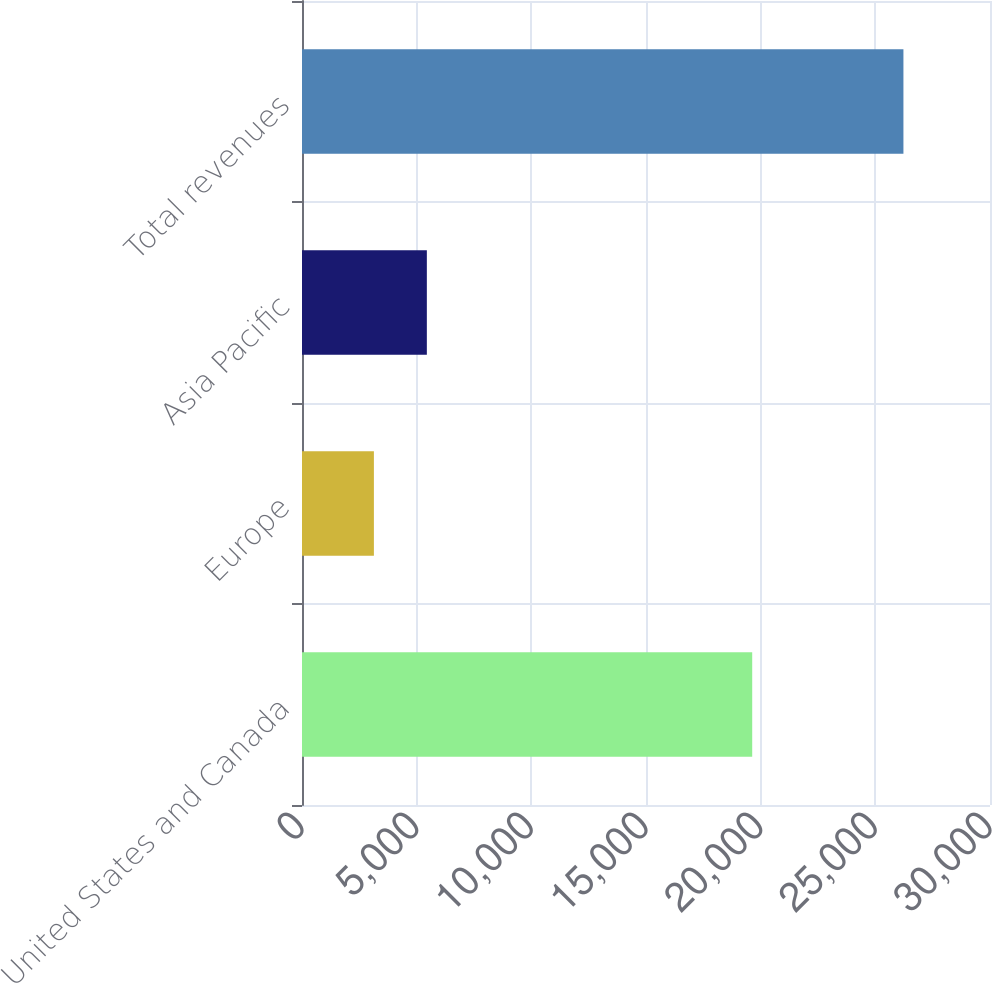Convert chart. <chart><loc_0><loc_0><loc_500><loc_500><bar_chart><fcel>United States and Canada<fcel>Europe<fcel>Asia Pacific<fcel>Total revenues<nl><fcel>19631<fcel>3135<fcel>5444<fcel>26225<nl></chart> 